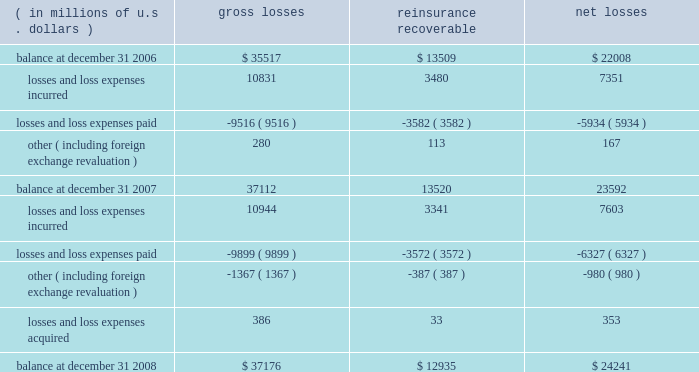We are continuing to invest in people and infrastructure to grow our presence in lines of businesses globally where we see an opportunity for ace to grow market share at reasonable terms .
We are also continuing to invest in our enterprise risk management capability , our systems and data environment , and our research and development capabilities .
Critical accounting estimates our consolidated financial statements include amounts that , either by their nature or due to requirements of accounting princi- ples generally accepted in the u.s .
( gaap ) , are determined using best estimates and assumptions .
While we believe that the amounts included in our consolidated financial statements reflect our best judgment , actual amounts could ultimately materi- ally differ from those currently presented .
We believe the items that require the most subjective and complex estimates are : 2022 unpaid loss and loss expense reserves , including long-tail asbestos and environmental ( a&e ) reserves ; 2022 future policy benefits reserves ; 2022 valuation of value of business acquired ( voba ) and amortization of deferred policy acquisition costs and voba ; 2022 the assessment of risk transfer for certain structured insurance and reinsurance contracts ; 2022 reinsurance recoverable , including a provision for uncollectible reinsurance ; 2022 impairments to the carrying value of our investment portfolio ; 2022 the valuation of deferred tax assets ; 2022 the valuation of derivative instruments related to guaranteed minimum income benefits ( gmib ) ; and 2022 the valuation of goodwill .
We believe our accounting policies for these items are of critical importance to our consolidated financial statements .
The following discussion provides more information regarding the estimates and assumptions required to arrive at these amounts and should be read in conjunction with the sections entitled : prior period development , asbestos and environmental and other run-off liabilities , reinsurance recoverable on ceded reinsurance , investments , net realized gains ( losses ) , and other income and expense items .
Unpaid losses and loss expenses as an insurance and reinsurance company , we are required , by applicable laws and regulations and gaap , to establish loss and loss expense reserves for the estimated unpaid portion of the ultimate liability for losses and loss expenses under the terms of our policies and agreements with our insured and reinsured customers .
The estimate of the liabilities includes provisions for claims that have been reported but unpaid at the balance sheet date ( case reserves ) and for future obligations from claims that have been incurred but not reported ( ibnr ) at the balance sheet date ( ibnr may also include a provision for additional devel- opment on reported claims in instances where the case reserve is viewed to be potentially insufficient ) .
The reserves provide for liabilities that exist for the company as of the balance sheet date .
The loss reserve also includes an estimate of expenses associated with processing and settling these unpaid claims ( loss expenses ) .
At december 31 , 2008 , our gross unpaid loss and loss expense reserves were $ 37.2 billion and our net unpaid loss and loss expense reserves were $ 24.2 billion .
With the exception of certain structured settlements , for which the timing and amount of future claim payments are reliably determi- nable , our loss reserves are not discounted for the time value of money .
In connection with such structured settlements , we carry reserves of $ 106 million ( net of discount ) .
The table below presents a roll-forward of our unpaid losses and loss expenses for the indicated periods .
( in millions of u.s .
Dollars ) losses reinsurance recoverable net losses .

What are is the net change in the balance of unpaid losses during 2008? 
Computations: (((7603 + -6327) + -980) + 353)
Answer: 649.0. 